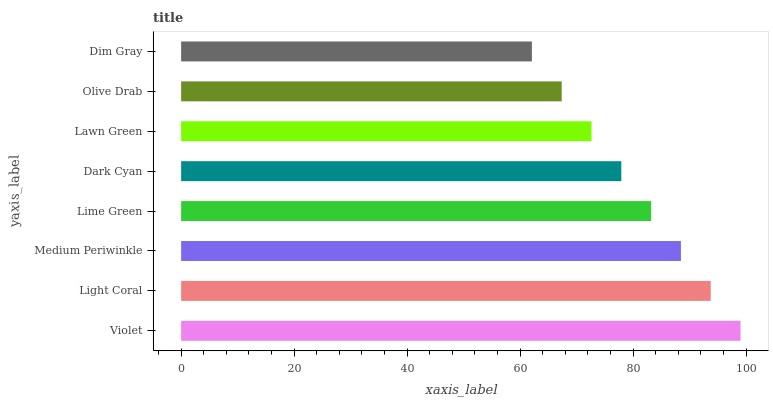Is Dim Gray the minimum?
Answer yes or no. Yes. Is Violet the maximum?
Answer yes or no. Yes. Is Light Coral the minimum?
Answer yes or no. No. Is Light Coral the maximum?
Answer yes or no. No. Is Violet greater than Light Coral?
Answer yes or no. Yes. Is Light Coral less than Violet?
Answer yes or no. Yes. Is Light Coral greater than Violet?
Answer yes or no. No. Is Violet less than Light Coral?
Answer yes or no. No. Is Lime Green the high median?
Answer yes or no. Yes. Is Dark Cyan the low median?
Answer yes or no. Yes. Is Violet the high median?
Answer yes or no. No. Is Lawn Green the low median?
Answer yes or no. No. 